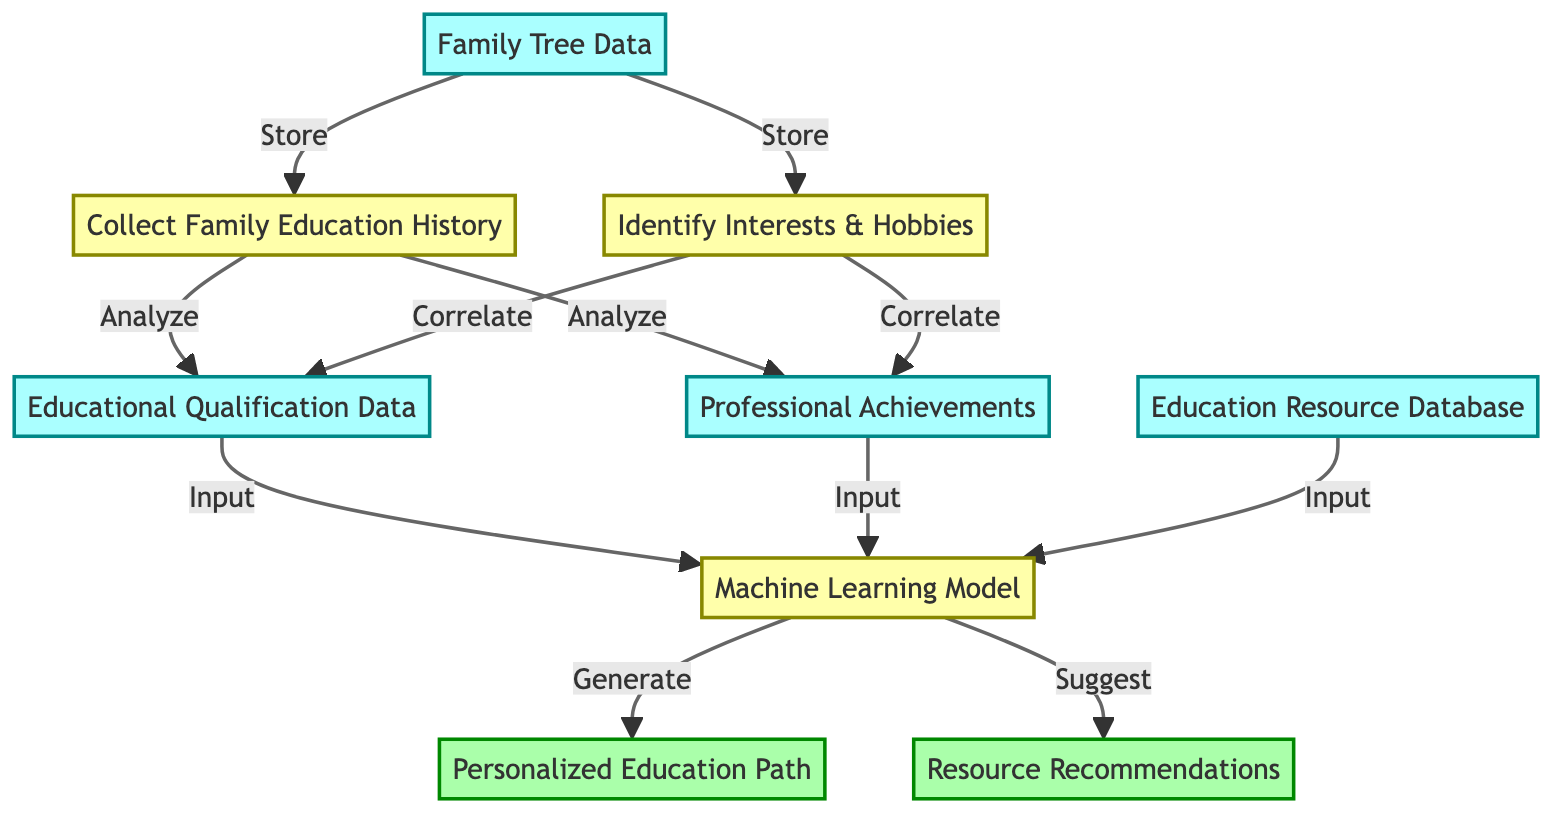What is the first input in the diagram? In the diagram, the first input node is labeled "Family Tree Data," which is the starting point of the flow in this personalized education suggestion system. It is the initial data that is used for further processing.
Answer: Family Tree Data How many output nodes are in the diagram? In the diagram, there are two output nodes labeled "Personalized Education Path" and "Resource Recommendations." Thus, the total number of output nodes is two.
Answer: 2 What is the process that analyzes family education history? The process labeled "Collect Family Education History" is responsible for analyzing the family education data collected from the family tree information. It processes this data to gain insights into educational backgrounds.
Answer: Collect Family Education History Which node correlates interests and hobbies with educational qualifications? The node labeled "Correlate" between "Identify Interests & Hobbies" and "Educational Qualification Data" signifies the process that combines interests and hobbies with educational qualifications to derive insights for recommendations.
Answer: Correlate What data sources does the Machine Learning Model require as input? The Machine Learning Model requires input from three sources: "Educational Qualification Data," "Professional Achievements," and "Education Resource Database." All three inputs provide necessary information for generating personalized education paths and recommendations.
Answer: Educational Qualification Data, Professional Achievements, Education Resource Database What is generated by the Machine Learning Model? The Machine Learning Model generates the "Personalized Education Path," which is an output crafted from the analysis and correlations made using the inputs provided to the model. It defines unique educational pathways suited to the children's background and interests.
Answer: Personalized Education Path Which two processes involve analysis? The two processes that involve analysis are "Collect Family Education History" and the correlation between "Identify Interests & Hobbies" and the educational qualifications and achievements. Both processes extract and interpret data to inform decisions.
Answer: Collect Family Education History, Correlate What is the direction of flow from "Resource Recommendations"? "Resource Recommendations" is an output node, and the direction of flow leads away from it since it represents suggestions generated by the Machine Learning Model based on the processed input data. The flow is outward, depicting that the recommendations are results of earlier computations.
Answer: Outward 